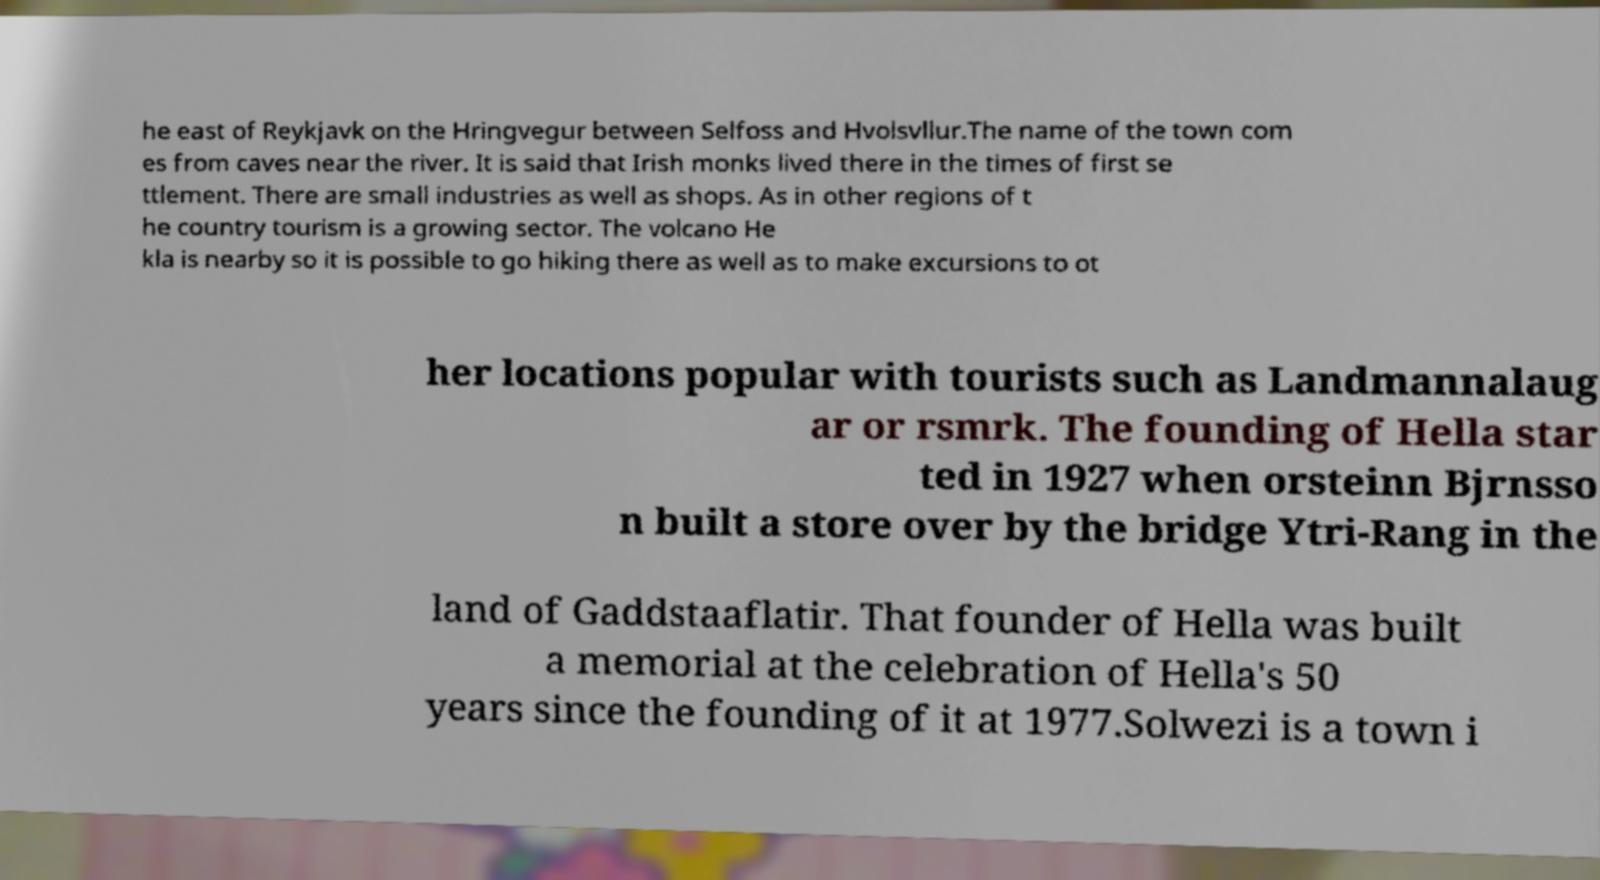Please read and relay the text visible in this image. What does it say? he east of Reykjavk on the Hringvegur between Selfoss and Hvolsvllur.The name of the town com es from caves near the river. It is said that Irish monks lived there in the times of first se ttlement. There are small industries as well as shops. As in other regions of t he country tourism is a growing sector. The volcano He kla is nearby so it is possible to go hiking there as well as to make excursions to ot her locations popular with tourists such as Landmannalaug ar or rsmrk. The founding of Hella star ted in 1927 when orsteinn Bjrnsso n built a store over by the bridge Ytri-Rang in the land of Gaddstaaflatir. That founder of Hella was built a memorial at the celebration of Hella's 50 years since the founding of it at 1977.Solwezi is a town i 